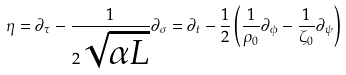Convert formula to latex. <formula><loc_0><loc_0><loc_500><loc_500>\eta = \partial _ { \tau } - \frac { 1 } { 2 \sqrt { \alpha L } } \partial _ { \sigma } = \partial _ { t } - \frac { 1 } { 2 } \left ( \frac { 1 } { \rho _ { 0 } } \partial _ { \phi } - \frac { 1 } { \zeta _ { 0 } } \partial _ { \psi } \right )</formula> 